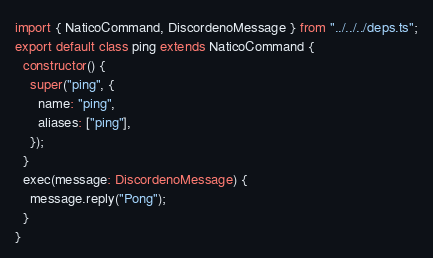<code> <loc_0><loc_0><loc_500><loc_500><_TypeScript_>import { NaticoCommand, DiscordenoMessage } from "../../../deps.ts";
export default class ping extends NaticoCommand {
  constructor() {
    super("ping", {
      name: "ping",
      aliases: ["ping"],
    });
  }
  exec(message: DiscordenoMessage) {
    message.reply("Pong");
  }
}
</code> 